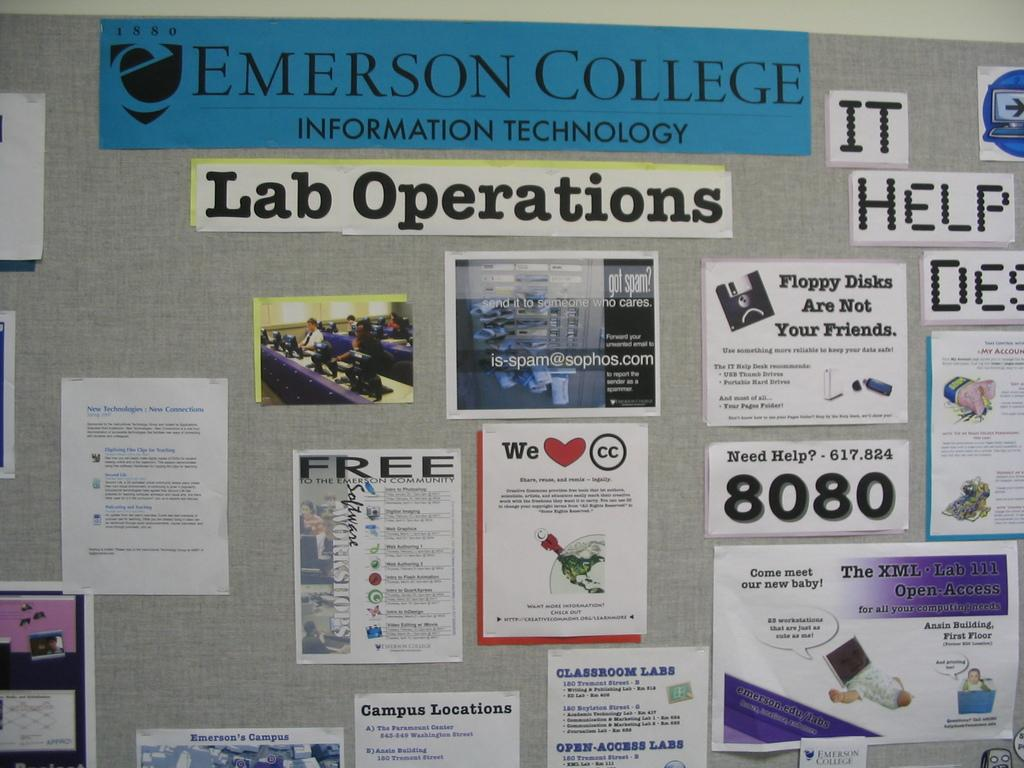What is located in the center of the image? There is a board in the center of the image. What is placed on the board? There are papers placed on the board. Can you see a robin perched on the board in the image? There is no robin present in the image. Is the board located near a dock in the image? There is no dock mentioned or visible in the image. 